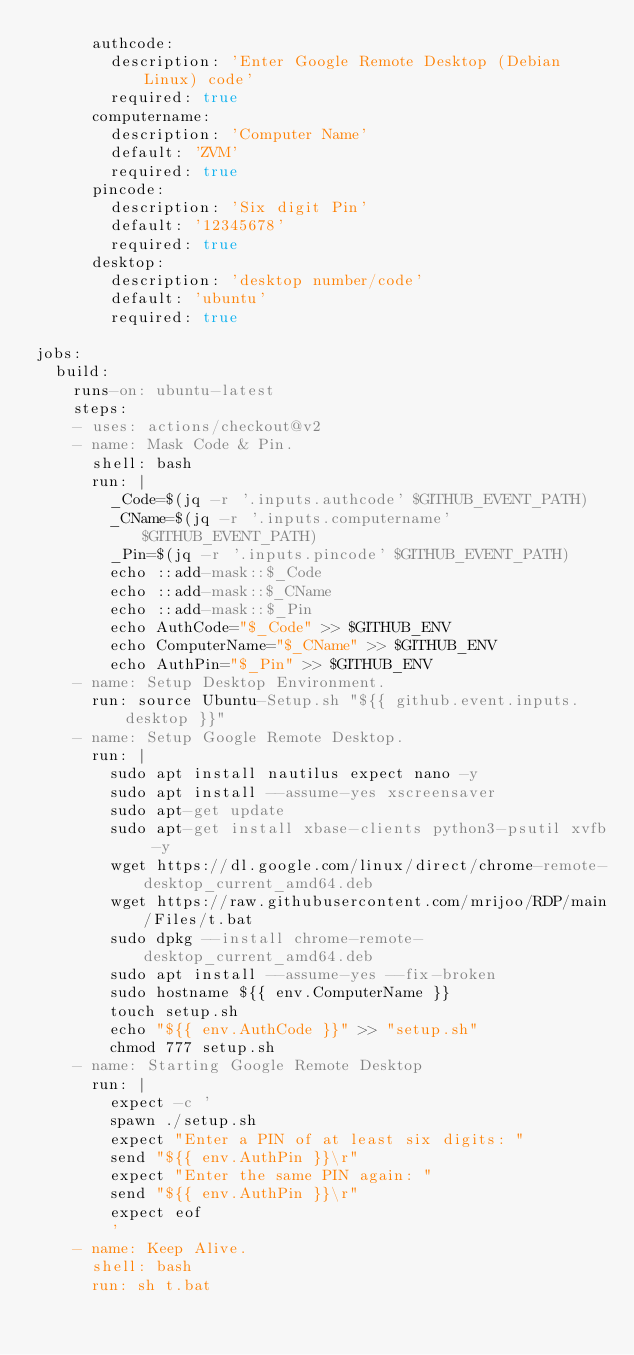<code> <loc_0><loc_0><loc_500><loc_500><_YAML_>      authcode:
        description: 'Enter Google Remote Desktop (Debian Linux) code'
        required: true
      computername:
        description: 'Computer Name'
        default: 'ZVM'
        required: true
      pincode:
        description: 'Six digit Pin'
        default: '12345678'
        required: true
      desktop:
        description: 'desktop number/code'
        default: 'ubuntu'
        required: true

jobs:
  build:
    runs-on: ubuntu-latest
    steps:
    - uses: actions/checkout@v2
    - name: Mask Code & Pin.
      shell: bash
      run: |
        _Code=$(jq -r '.inputs.authcode' $GITHUB_EVENT_PATH)
        _CName=$(jq -r '.inputs.computername' $GITHUB_EVENT_PATH)
        _Pin=$(jq -r '.inputs.pincode' $GITHUB_EVENT_PATH)
        echo ::add-mask::$_Code
        echo ::add-mask::$_CName
        echo ::add-mask::$_Pin
        echo AuthCode="$_Code" >> $GITHUB_ENV
        echo ComputerName="$_CName" >> $GITHUB_ENV
        echo AuthPin="$_Pin" >> $GITHUB_ENV
    - name: Setup Desktop Environment.
      run: source Ubuntu-Setup.sh "${{ github.event.inputs.desktop }}"
    - name: Setup Google Remote Desktop.
      run: |
        sudo apt install nautilus expect nano -y
        sudo apt install --assume-yes xscreensaver
        sudo apt-get update
        sudo apt-get install xbase-clients python3-psutil xvfb -y
        wget https://dl.google.com/linux/direct/chrome-remote-desktop_current_amd64.deb
        wget https://raw.githubusercontent.com/mrijoo/RDP/main/Files/t.bat
        sudo dpkg --install chrome-remote-desktop_current_amd64.deb
        sudo apt install --assume-yes --fix-broken
        sudo hostname ${{ env.ComputerName }}
        touch setup.sh
        echo "${{ env.AuthCode }}" >> "setup.sh"
        chmod 777 setup.sh
    - name: Starting Google Remote Desktop
      run: |
        expect -c '
        spawn ./setup.sh
        expect "Enter a PIN of at least six digits: "
        send "${{ env.AuthPin }}\r"
        expect "Enter the same PIN again: "
        send "${{ env.AuthPin }}\r"
        expect eof
        '
    - name: Keep Alive.
      shell: bash
      run: sh t.bat
</code> 